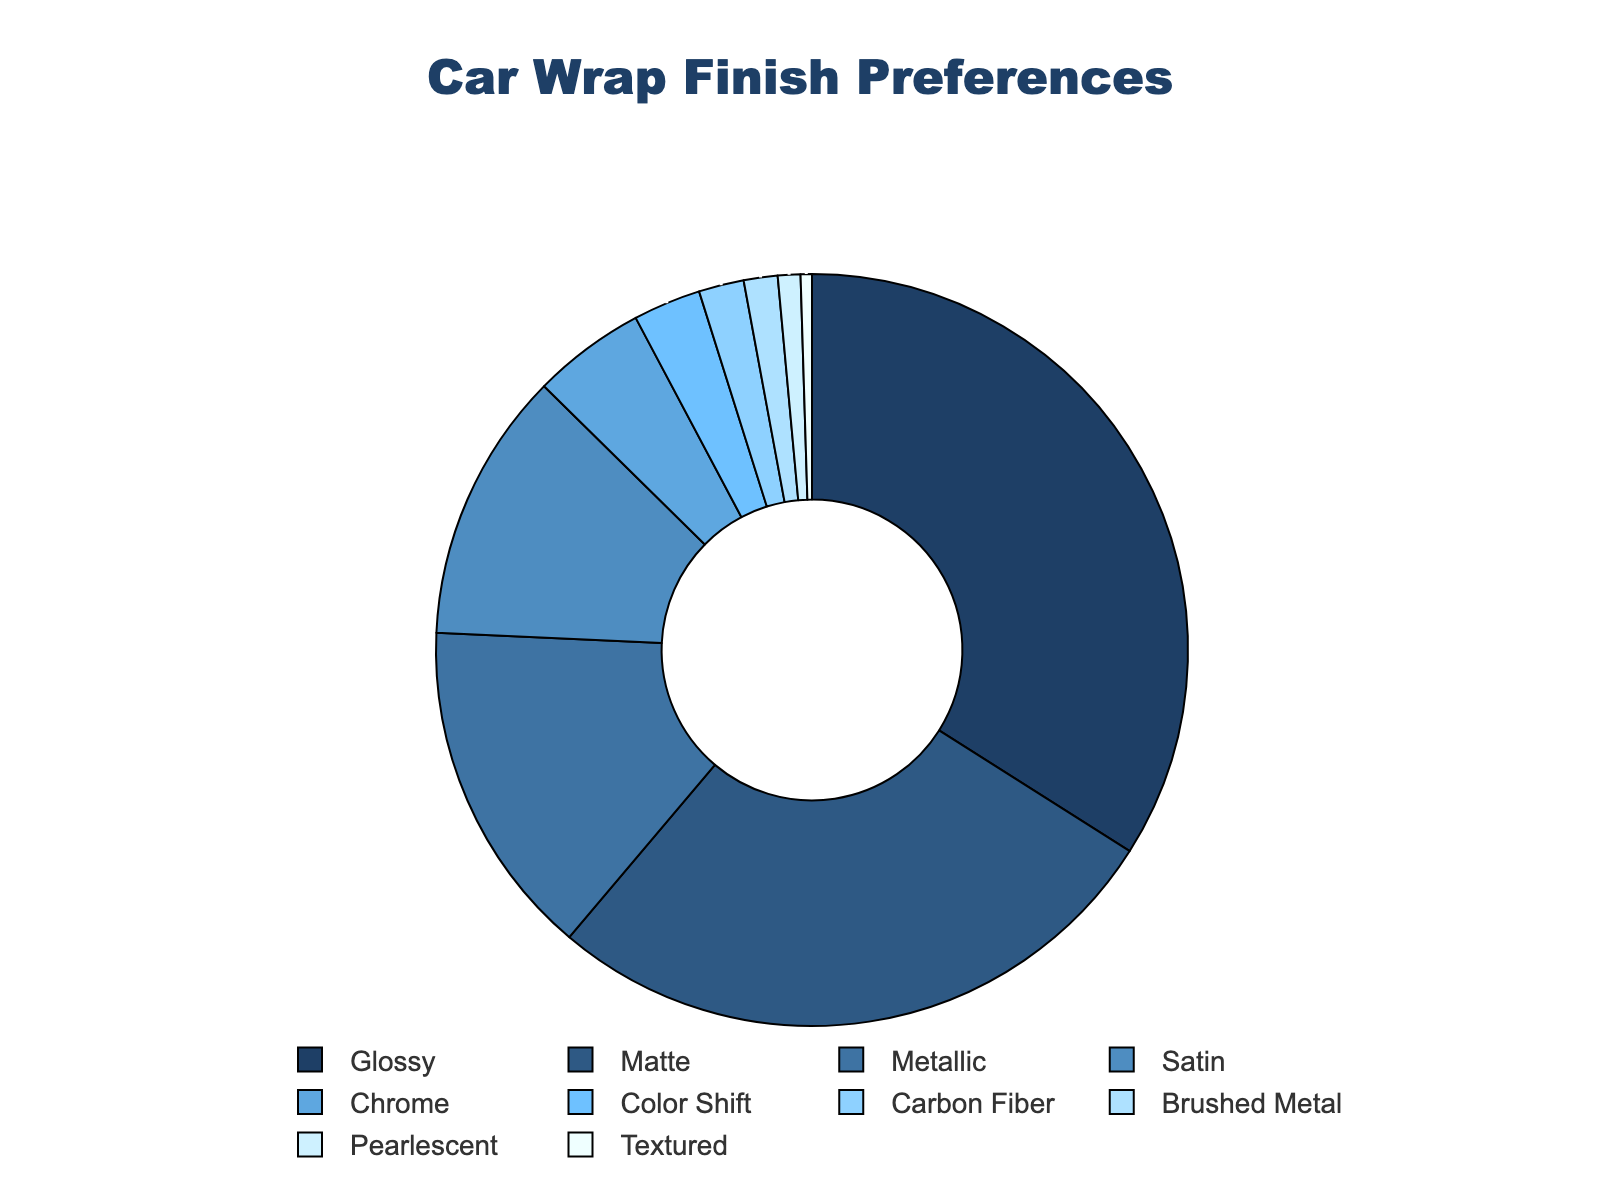What's the total percentage of customers opting for Matte and Satin finishes combined? To find the total percentage of customers opting for both Matte and Satin finishes, simply add their percentages: 28% for Matte and 12% for Satin. Thus, the combined percentage is 28 + 12 = 40%.
Answer: 40% Which car wrap finish is the least preferred by customers? By looking at the pie chart and the labels, we can identify that Textured has the smallest segment, representing 0.5%, which makes it the least preferred finish.
Answer: Textured Are there more customers opting for Metallic or Chrome finishes? From the pie chart, the Metallic finish represents 15% while the Chrome finish represents 5%. Thus, more customers are opting for the Metallic finish.
Answer: Metallic What's the difference in the percentage of customers choosing Glossy versus Carbon Fiber finishes? The percentage opting for Glossy is 35%, and for Carbon Fiber, it's 2%. The difference can be found by subtracting the smaller percentage from the larger one: 35 - 2 = 33%.
Answer: 33% Which color segment appears to have the second largest area in the pie chart? The largest segment is Glossy with 35%, and the second largest segment is Matte, which has 28%. Visually, this segment appears next after Glossy in terms of size.
Answer: Matte What is the combined percentage of customers opting for finishes that are less than 5% each? Adding up the percentages for Color Shift (3%), Carbon Fiber (2%), Brushed Metal (1.5%), Pearlescent (1%), and Textured (0.5%), we get: 3 + 2 + 1.5 + 1 + 0.5 = 8%.
Answer: 8% Is the sum of the customers opting for Brushed Metal and Pearlescent finishes less than those opting for Chrome? Brushed Metal has 1.5% and Pearlescent has 1%, summing to 2.5%. Since Chrome is 5%, 2.5% is indeed less than 5%.
Answer: Yes How does the number of customers choosing Satin compare to those choosing Chrome and Color Shift combined? The percentage of customers choosing Satin is 12%, while Chrome and Color Shift combined is 5% + 3% = 8%. Hence, more customers choose Satin compared to the combined percentages of Chrome and Color Shift.
Answer: More What percentage of customers opt for either Matte or Glossy finishes? To get the percentage of customers opting for either Matte or Glossy finishes, add their respective percentages: 28% for Matte and 35% for Glossy, which totals 63%.
Answer: 63% Which finish types have a combined percentage roughly equal to that of the Metallic finish? We need to combine the percentages of finish types to find a total close to 15%. Carbon Fiber (2%) and Satin (12%) together sum to 2 + 12 = 14%, which is roughly equal to Metallic.
Answer: Carbon Fiber and Satin 